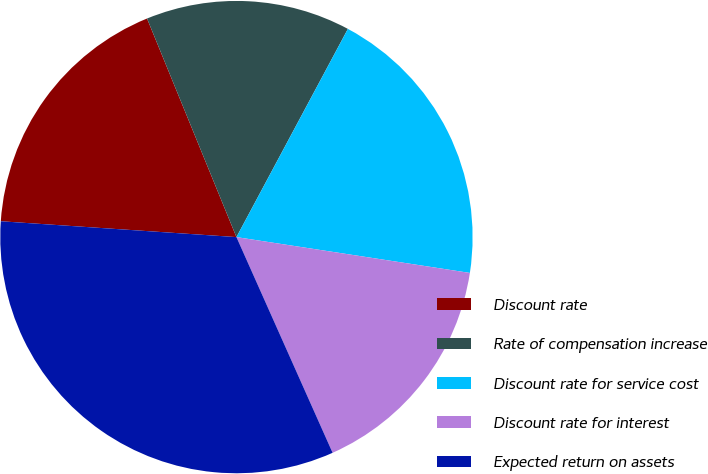Convert chart. <chart><loc_0><loc_0><loc_500><loc_500><pie_chart><fcel>Discount rate<fcel>Rate of compensation increase<fcel>Discount rate for service cost<fcel>Discount rate for interest<fcel>Expected return on assets<nl><fcel>17.75%<fcel>14.0%<fcel>19.6%<fcel>15.9%<fcel>32.74%<nl></chart> 